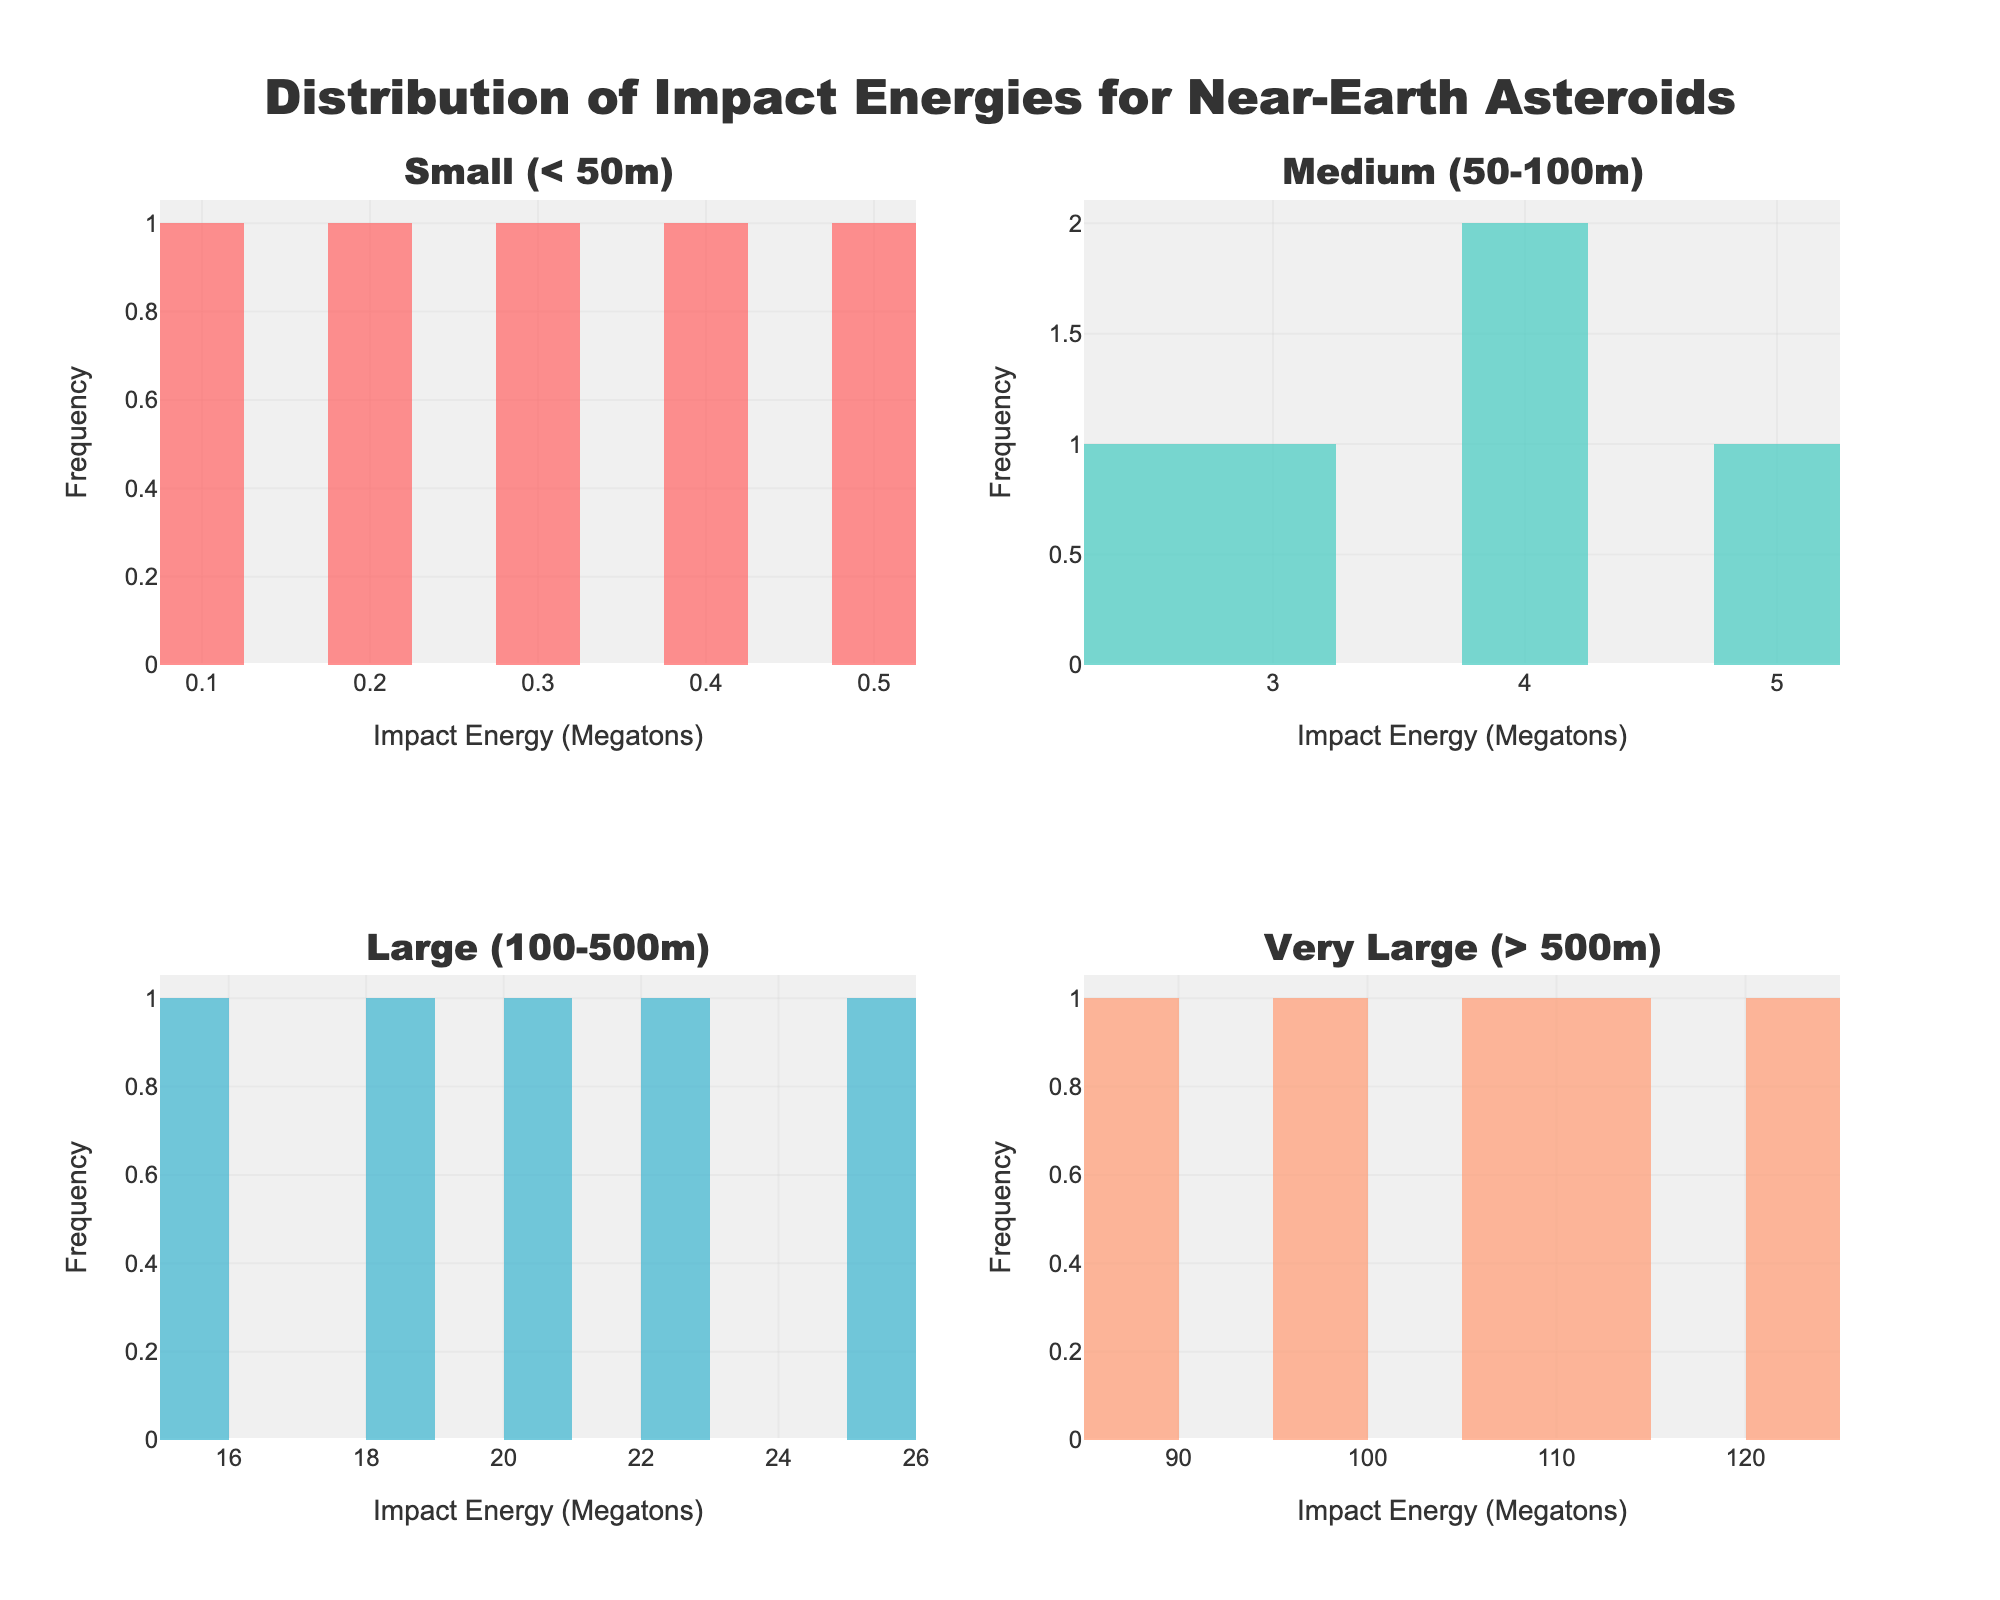What is the title of the figure? The figure's title is displayed at the top, which is "Distribution of Impact Energies for Near-Earth Asteroids".
Answer: Distribution of Impact Energies for Near-Earth Asteroids How many subplots are there in the figure? The figure has subplots for each asteroid size category, arranged in a 2x2 grid, making a total of 4 subplots.
Answer: 4 What is the range of impact energy for small (< 50m) asteroids? The impact energies for small asteroids are provided in the plot axes labels. They range from 0.1 to 0.5 megatons.
Answer: 0.1 to 0.5 megatons Which asteroid size category has the highest impact energy? By analyzing all the subplots, the Very Large (> 500m) asteroid category has the highest impact energy values, with values up to 120.2 megatons.
Answer: Very Large (> 500m) Which size category has the most concentrated (narrow range) impact energy values? By examining the spread of the histograms, the Small (< 50m) category appears most concentrated, as the values are all within a very narrow range (0.1 to 0.5 megatons).
Answer: Small (< 50m) What is the median impact energy for Medium (50-100m) asteroids? To find the median, we sort the impact energies for Medium asteroids (2.5, 3.1, 3.8, 4.2, 5.0). The median value is the middle one in the sorted list, which is 3.8 megatons.
Answer: 3.8 megatons How does the distribution of Large (100-500m) asteroid impact energies compare to Very Large (> 500m) asteroid impact energies? Very Large asteroids have a broader range and higher values in the histogram compared to Large asteroids, which have lower and more narrowly distributed impact energies.
Answer: Very Large asteroids have higher and more varied impact energies What can you infer about the frequency of high-energy impacts for Very Large asteroids? The histogram for Very Large asteroids shows that high-energy impacts are more frequent in this category, as the histogram has significant bars even at higher megaton values.
Answer: High-energy impacts are more frequent Which histogram color represents the Medium (50-100m) asteroid size category? Each size category is represented by a unique color in the histogram. The Medium (50-100m) category is colored in '#4ECDC4' (turquoise).
Answer: Turquoise 